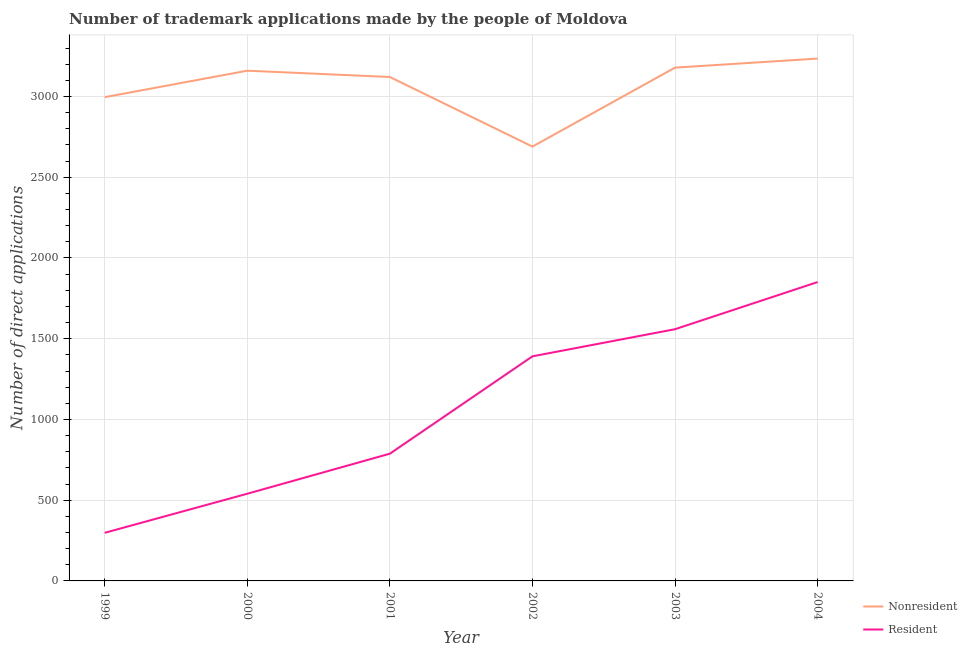Is the number of lines equal to the number of legend labels?
Provide a short and direct response. Yes. What is the number of trademark applications made by non residents in 2002?
Keep it short and to the point. 2690. Across all years, what is the maximum number of trademark applications made by residents?
Make the answer very short. 1851. Across all years, what is the minimum number of trademark applications made by non residents?
Provide a short and direct response. 2690. In which year was the number of trademark applications made by non residents minimum?
Make the answer very short. 2002. What is the total number of trademark applications made by residents in the graph?
Ensure brevity in your answer.  6427. What is the difference between the number of trademark applications made by non residents in 1999 and that in 2003?
Your answer should be very brief. -183. What is the difference between the number of trademark applications made by non residents in 1999 and the number of trademark applications made by residents in 2001?
Give a very brief answer. 2208. What is the average number of trademark applications made by residents per year?
Provide a short and direct response. 1071.17. In the year 2000, what is the difference between the number of trademark applications made by non residents and number of trademark applications made by residents?
Provide a short and direct response. 2620. What is the ratio of the number of trademark applications made by residents in 1999 to that in 2003?
Provide a short and direct response. 0.19. Is the number of trademark applications made by residents in 1999 less than that in 2000?
Provide a short and direct response. Yes. What is the difference between the highest and the lowest number of trademark applications made by residents?
Keep it short and to the point. 1553. Are the values on the major ticks of Y-axis written in scientific E-notation?
Offer a terse response. No. Where does the legend appear in the graph?
Ensure brevity in your answer.  Bottom right. How many legend labels are there?
Give a very brief answer. 2. What is the title of the graph?
Provide a short and direct response. Number of trademark applications made by the people of Moldova. What is the label or title of the Y-axis?
Provide a succinct answer. Number of direct applications. What is the Number of direct applications of Nonresident in 1999?
Provide a succinct answer. 2996. What is the Number of direct applications in Resident in 1999?
Make the answer very short. 298. What is the Number of direct applications of Nonresident in 2000?
Provide a short and direct response. 3160. What is the Number of direct applications of Resident in 2000?
Your answer should be very brief. 540. What is the Number of direct applications in Nonresident in 2001?
Keep it short and to the point. 3121. What is the Number of direct applications in Resident in 2001?
Provide a short and direct response. 788. What is the Number of direct applications of Nonresident in 2002?
Provide a succinct answer. 2690. What is the Number of direct applications of Resident in 2002?
Your answer should be compact. 1391. What is the Number of direct applications of Nonresident in 2003?
Offer a terse response. 3179. What is the Number of direct applications in Resident in 2003?
Ensure brevity in your answer.  1559. What is the Number of direct applications in Nonresident in 2004?
Offer a terse response. 3235. What is the Number of direct applications of Resident in 2004?
Offer a very short reply. 1851. Across all years, what is the maximum Number of direct applications in Nonresident?
Offer a terse response. 3235. Across all years, what is the maximum Number of direct applications in Resident?
Offer a terse response. 1851. Across all years, what is the minimum Number of direct applications of Nonresident?
Keep it short and to the point. 2690. Across all years, what is the minimum Number of direct applications in Resident?
Your answer should be compact. 298. What is the total Number of direct applications in Nonresident in the graph?
Your response must be concise. 1.84e+04. What is the total Number of direct applications in Resident in the graph?
Your answer should be compact. 6427. What is the difference between the Number of direct applications of Nonresident in 1999 and that in 2000?
Provide a succinct answer. -164. What is the difference between the Number of direct applications of Resident in 1999 and that in 2000?
Offer a terse response. -242. What is the difference between the Number of direct applications in Nonresident in 1999 and that in 2001?
Your answer should be very brief. -125. What is the difference between the Number of direct applications of Resident in 1999 and that in 2001?
Your answer should be compact. -490. What is the difference between the Number of direct applications of Nonresident in 1999 and that in 2002?
Keep it short and to the point. 306. What is the difference between the Number of direct applications of Resident in 1999 and that in 2002?
Provide a succinct answer. -1093. What is the difference between the Number of direct applications in Nonresident in 1999 and that in 2003?
Keep it short and to the point. -183. What is the difference between the Number of direct applications of Resident in 1999 and that in 2003?
Provide a succinct answer. -1261. What is the difference between the Number of direct applications of Nonresident in 1999 and that in 2004?
Your answer should be very brief. -239. What is the difference between the Number of direct applications in Resident in 1999 and that in 2004?
Provide a short and direct response. -1553. What is the difference between the Number of direct applications of Resident in 2000 and that in 2001?
Ensure brevity in your answer.  -248. What is the difference between the Number of direct applications of Nonresident in 2000 and that in 2002?
Give a very brief answer. 470. What is the difference between the Number of direct applications in Resident in 2000 and that in 2002?
Give a very brief answer. -851. What is the difference between the Number of direct applications in Nonresident in 2000 and that in 2003?
Your response must be concise. -19. What is the difference between the Number of direct applications of Resident in 2000 and that in 2003?
Your answer should be very brief. -1019. What is the difference between the Number of direct applications of Nonresident in 2000 and that in 2004?
Offer a very short reply. -75. What is the difference between the Number of direct applications of Resident in 2000 and that in 2004?
Your response must be concise. -1311. What is the difference between the Number of direct applications of Nonresident in 2001 and that in 2002?
Offer a terse response. 431. What is the difference between the Number of direct applications of Resident in 2001 and that in 2002?
Keep it short and to the point. -603. What is the difference between the Number of direct applications in Nonresident in 2001 and that in 2003?
Offer a terse response. -58. What is the difference between the Number of direct applications of Resident in 2001 and that in 2003?
Keep it short and to the point. -771. What is the difference between the Number of direct applications in Nonresident in 2001 and that in 2004?
Your response must be concise. -114. What is the difference between the Number of direct applications of Resident in 2001 and that in 2004?
Provide a short and direct response. -1063. What is the difference between the Number of direct applications in Nonresident in 2002 and that in 2003?
Offer a terse response. -489. What is the difference between the Number of direct applications of Resident in 2002 and that in 2003?
Provide a succinct answer. -168. What is the difference between the Number of direct applications in Nonresident in 2002 and that in 2004?
Your response must be concise. -545. What is the difference between the Number of direct applications in Resident in 2002 and that in 2004?
Provide a succinct answer. -460. What is the difference between the Number of direct applications of Nonresident in 2003 and that in 2004?
Provide a short and direct response. -56. What is the difference between the Number of direct applications of Resident in 2003 and that in 2004?
Provide a succinct answer. -292. What is the difference between the Number of direct applications in Nonresident in 1999 and the Number of direct applications in Resident in 2000?
Your answer should be very brief. 2456. What is the difference between the Number of direct applications in Nonresident in 1999 and the Number of direct applications in Resident in 2001?
Your answer should be very brief. 2208. What is the difference between the Number of direct applications of Nonresident in 1999 and the Number of direct applications of Resident in 2002?
Your response must be concise. 1605. What is the difference between the Number of direct applications in Nonresident in 1999 and the Number of direct applications in Resident in 2003?
Offer a very short reply. 1437. What is the difference between the Number of direct applications of Nonresident in 1999 and the Number of direct applications of Resident in 2004?
Ensure brevity in your answer.  1145. What is the difference between the Number of direct applications in Nonresident in 2000 and the Number of direct applications in Resident in 2001?
Your answer should be very brief. 2372. What is the difference between the Number of direct applications of Nonresident in 2000 and the Number of direct applications of Resident in 2002?
Ensure brevity in your answer.  1769. What is the difference between the Number of direct applications of Nonresident in 2000 and the Number of direct applications of Resident in 2003?
Offer a very short reply. 1601. What is the difference between the Number of direct applications of Nonresident in 2000 and the Number of direct applications of Resident in 2004?
Provide a short and direct response. 1309. What is the difference between the Number of direct applications in Nonresident in 2001 and the Number of direct applications in Resident in 2002?
Offer a terse response. 1730. What is the difference between the Number of direct applications in Nonresident in 2001 and the Number of direct applications in Resident in 2003?
Your answer should be very brief. 1562. What is the difference between the Number of direct applications in Nonresident in 2001 and the Number of direct applications in Resident in 2004?
Provide a short and direct response. 1270. What is the difference between the Number of direct applications of Nonresident in 2002 and the Number of direct applications of Resident in 2003?
Ensure brevity in your answer.  1131. What is the difference between the Number of direct applications of Nonresident in 2002 and the Number of direct applications of Resident in 2004?
Provide a succinct answer. 839. What is the difference between the Number of direct applications in Nonresident in 2003 and the Number of direct applications in Resident in 2004?
Provide a succinct answer. 1328. What is the average Number of direct applications in Nonresident per year?
Your answer should be very brief. 3063.5. What is the average Number of direct applications of Resident per year?
Give a very brief answer. 1071.17. In the year 1999, what is the difference between the Number of direct applications in Nonresident and Number of direct applications in Resident?
Your answer should be very brief. 2698. In the year 2000, what is the difference between the Number of direct applications of Nonresident and Number of direct applications of Resident?
Provide a succinct answer. 2620. In the year 2001, what is the difference between the Number of direct applications of Nonresident and Number of direct applications of Resident?
Provide a short and direct response. 2333. In the year 2002, what is the difference between the Number of direct applications in Nonresident and Number of direct applications in Resident?
Make the answer very short. 1299. In the year 2003, what is the difference between the Number of direct applications in Nonresident and Number of direct applications in Resident?
Your answer should be compact. 1620. In the year 2004, what is the difference between the Number of direct applications of Nonresident and Number of direct applications of Resident?
Offer a terse response. 1384. What is the ratio of the Number of direct applications in Nonresident in 1999 to that in 2000?
Provide a short and direct response. 0.95. What is the ratio of the Number of direct applications of Resident in 1999 to that in 2000?
Keep it short and to the point. 0.55. What is the ratio of the Number of direct applications of Nonresident in 1999 to that in 2001?
Ensure brevity in your answer.  0.96. What is the ratio of the Number of direct applications in Resident in 1999 to that in 2001?
Make the answer very short. 0.38. What is the ratio of the Number of direct applications of Nonresident in 1999 to that in 2002?
Keep it short and to the point. 1.11. What is the ratio of the Number of direct applications of Resident in 1999 to that in 2002?
Provide a short and direct response. 0.21. What is the ratio of the Number of direct applications in Nonresident in 1999 to that in 2003?
Give a very brief answer. 0.94. What is the ratio of the Number of direct applications of Resident in 1999 to that in 2003?
Make the answer very short. 0.19. What is the ratio of the Number of direct applications of Nonresident in 1999 to that in 2004?
Make the answer very short. 0.93. What is the ratio of the Number of direct applications in Resident in 1999 to that in 2004?
Make the answer very short. 0.16. What is the ratio of the Number of direct applications of Nonresident in 2000 to that in 2001?
Your answer should be compact. 1.01. What is the ratio of the Number of direct applications in Resident in 2000 to that in 2001?
Keep it short and to the point. 0.69. What is the ratio of the Number of direct applications in Nonresident in 2000 to that in 2002?
Give a very brief answer. 1.17. What is the ratio of the Number of direct applications of Resident in 2000 to that in 2002?
Your response must be concise. 0.39. What is the ratio of the Number of direct applications of Resident in 2000 to that in 2003?
Provide a short and direct response. 0.35. What is the ratio of the Number of direct applications in Nonresident in 2000 to that in 2004?
Provide a succinct answer. 0.98. What is the ratio of the Number of direct applications in Resident in 2000 to that in 2004?
Provide a succinct answer. 0.29. What is the ratio of the Number of direct applications of Nonresident in 2001 to that in 2002?
Keep it short and to the point. 1.16. What is the ratio of the Number of direct applications of Resident in 2001 to that in 2002?
Your answer should be very brief. 0.57. What is the ratio of the Number of direct applications in Nonresident in 2001 to that in 2003?
Ensure brevity in your answer.  0.98. What is the ratio of the Number of direct applications in Resident in 2001 to that in 2003?
Provide a short and direct response. 0.51. What is the ratio of the Number of direct applications in Nonresident in 2001 to that in 2004?
Provide a succinct answer. 0.96. What is the ratio of the Number of direct applications in Resident in 2001 to that in 2004?
Your response must be concise. 0.43. What is the ratio of the Number of direct applications in Nonresident in 2002 to that in 2003?
Make the answer very short. 0.85. What is the ratio of the Number of direct applications of Resident in 2002 to that in 2003?
Keep it short and to the point. 0.89. What is the ratio of the Number of direct applications in Nonresident in 2002 to that in 2004?
Offer a terse response. 0.83. What is the ratio of the Number of direct applications of Resident in 2002 to that in 2004?
Your response must be concise. 0.75. What is the ratio of the Number of direct applications of Nonresident in 2003 to that in 2004?
Offer a terse response. 0.98. What is the ratio of the Number of direct applications in Resident in 2003 to that in 2004?
Provide a short and direct response. 0.84. What is the difference between the highest and the second highest Number of direct applications of Resident?
Make the answer very short. 292. What is the difference between the highest and the lowest Number of direct applications of Nonresident?
Your answer should be compact. 545. What is the difference between the highest and the lowest Number of direct applications of Resident?
Your answer should be very brief. 1553. 